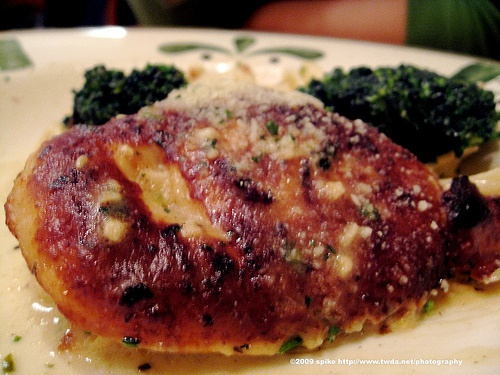Describe the objects in this image and their specific colors. I can see broccoli in black, darkgreen, and gray tones and broccoli in black, darkgreen, and gray tones in this image. 